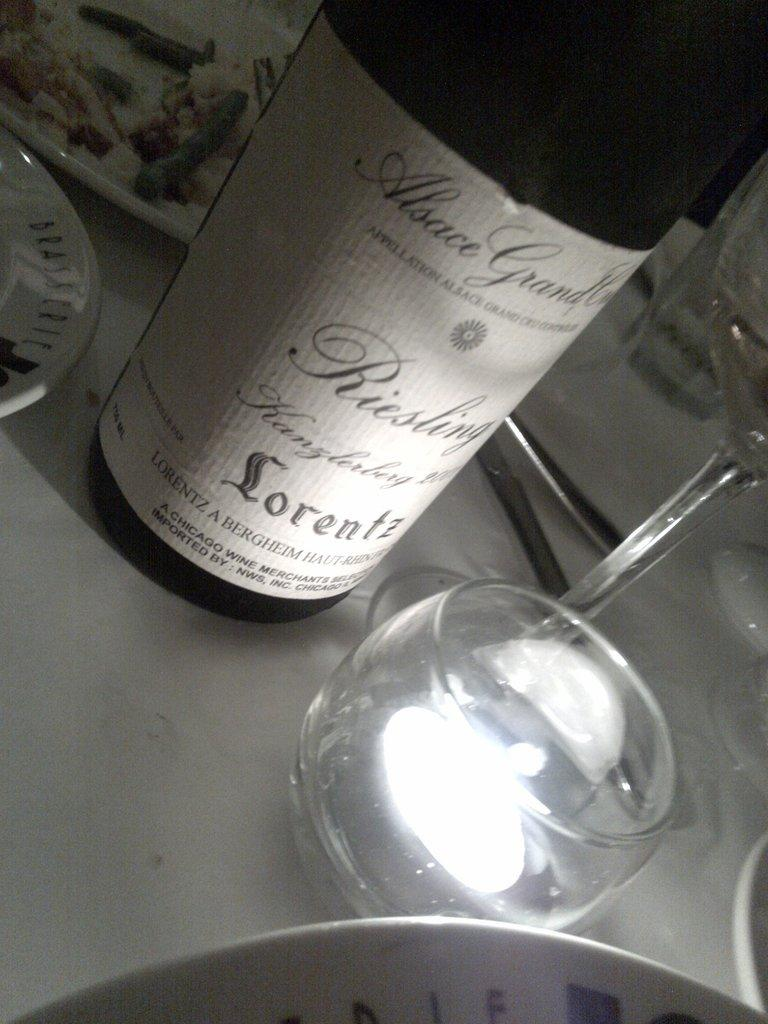<image>
Summarize the visual content of the image. The Lorentz wine bottle is described as a "Chicago Wine" which is labeled at the bottom of the bottle. 